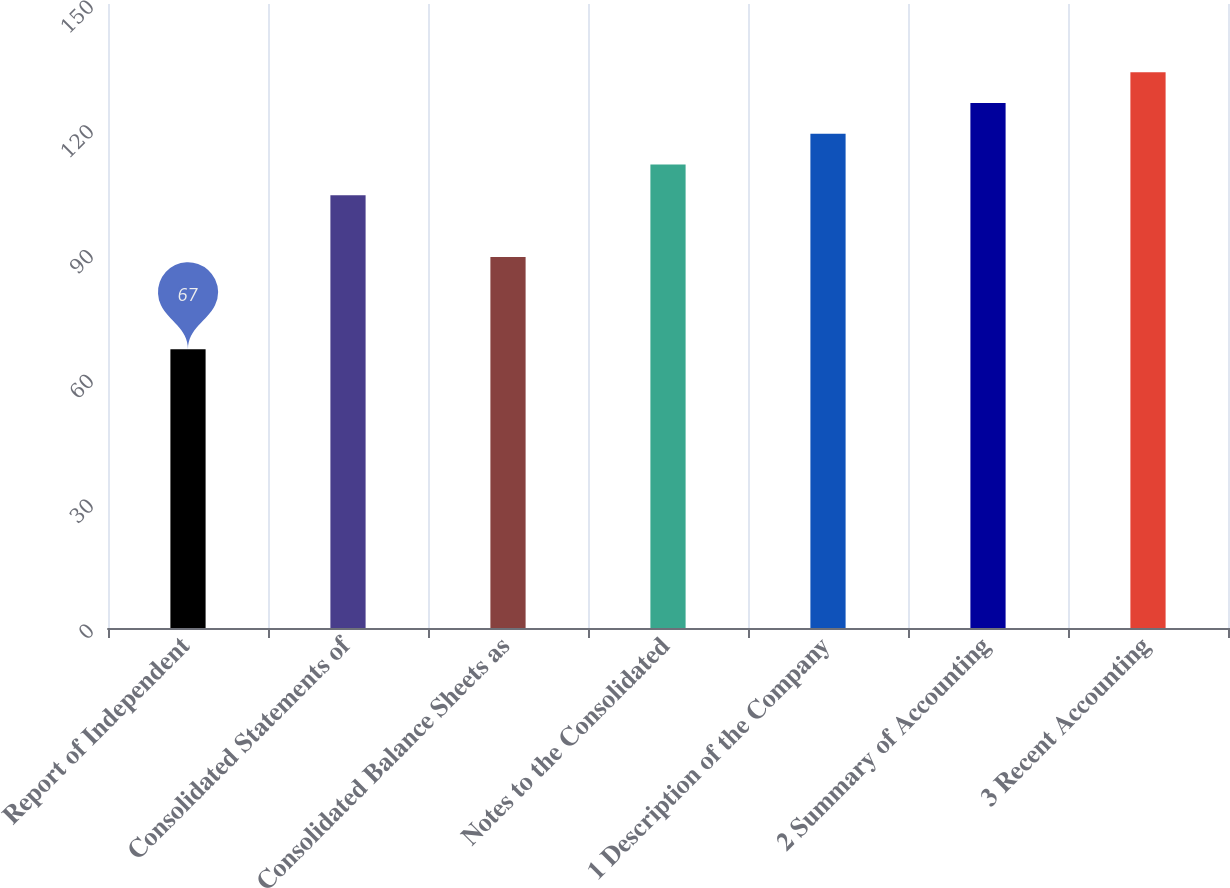Convert chart to OTSL. <chart><loc_0><loc_0><loc_500><loc_500><bar_chart><fcel>Report of Independent<fcel>Consolidated Statements of<fcel>Consolidated Balance Sheets as<fcel>Notes to the Consolidated<fcel>1 Description of the Company<fcel>2 Summary of Accounting<fcel>3 Recent Accounting<nl><fcel>67<fcel>104<fcel>89.2<fcel>111.4<fcel>118.8<fcel>126.2<fcel>133.6<nl></chart> 